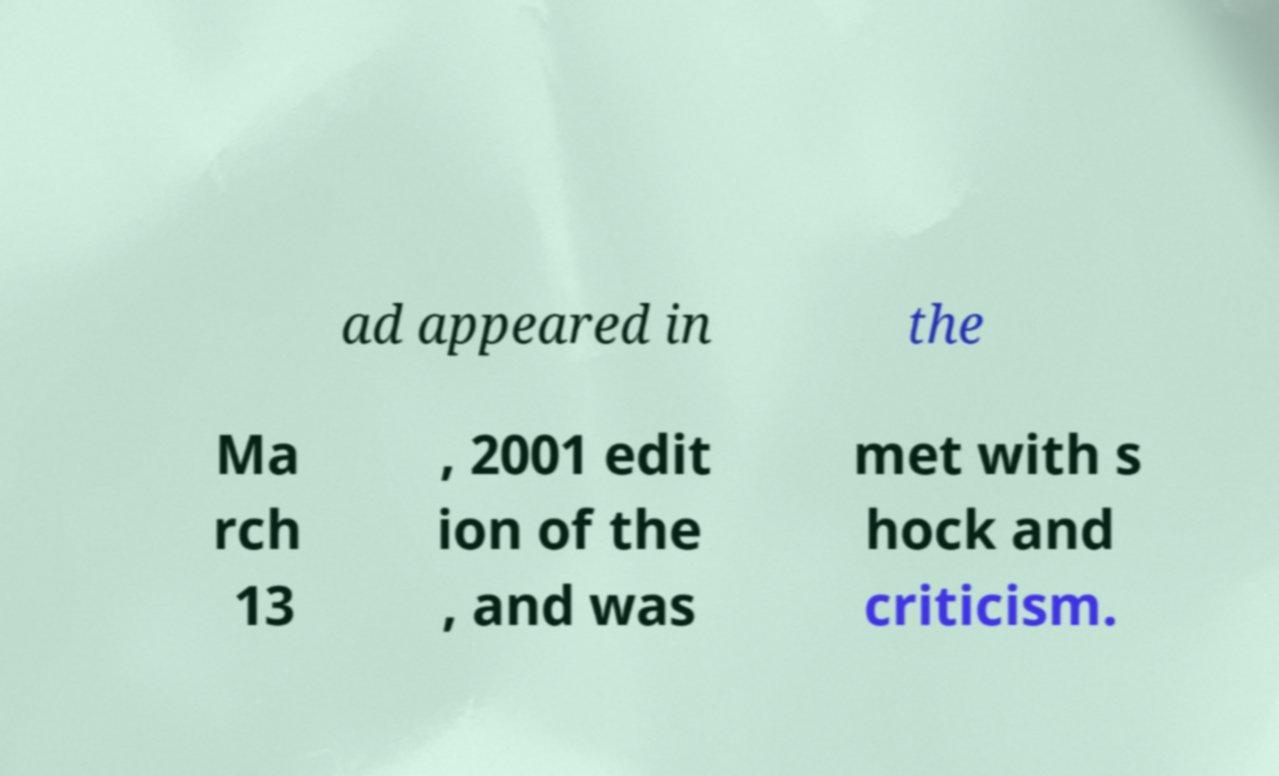For documentation purposes, I need the text within this image transcribed. Could you provide that? ad appeared in the Ma rch 13 , 2001 edit ion of the , and was met with s hock and criticism. 